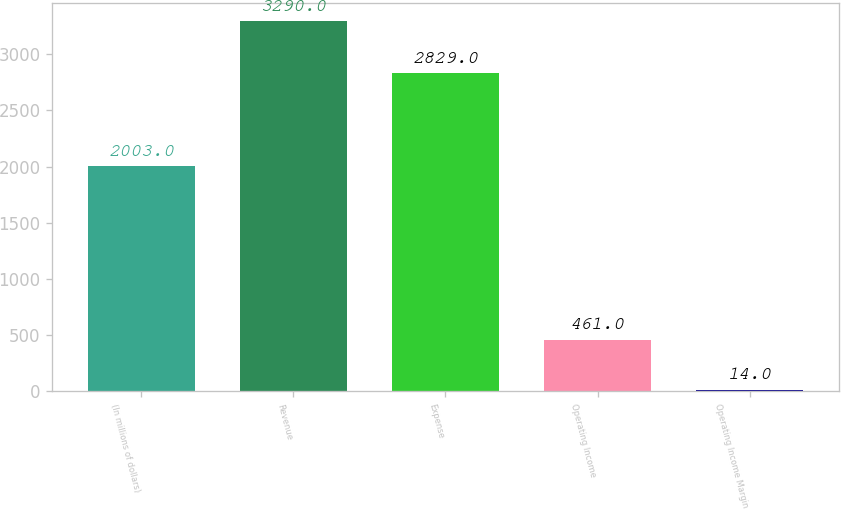<chart> <loc_0><loc_0><loc_500><loc_500><bar_chart><fcel>(In millions of dollars)<fcel>Revenue<fcel>Expense<fcel>Operating Income<fcel>Operating Income Margin<nl><fcel>2003<fcel>3290<fcel>2829<fcel>461<fcel>14<nl></chart> 